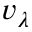Convert formula to latex. <formula><loc_0><loc_0><loc_500><loc_500>v _ { \lambda }</formula> 